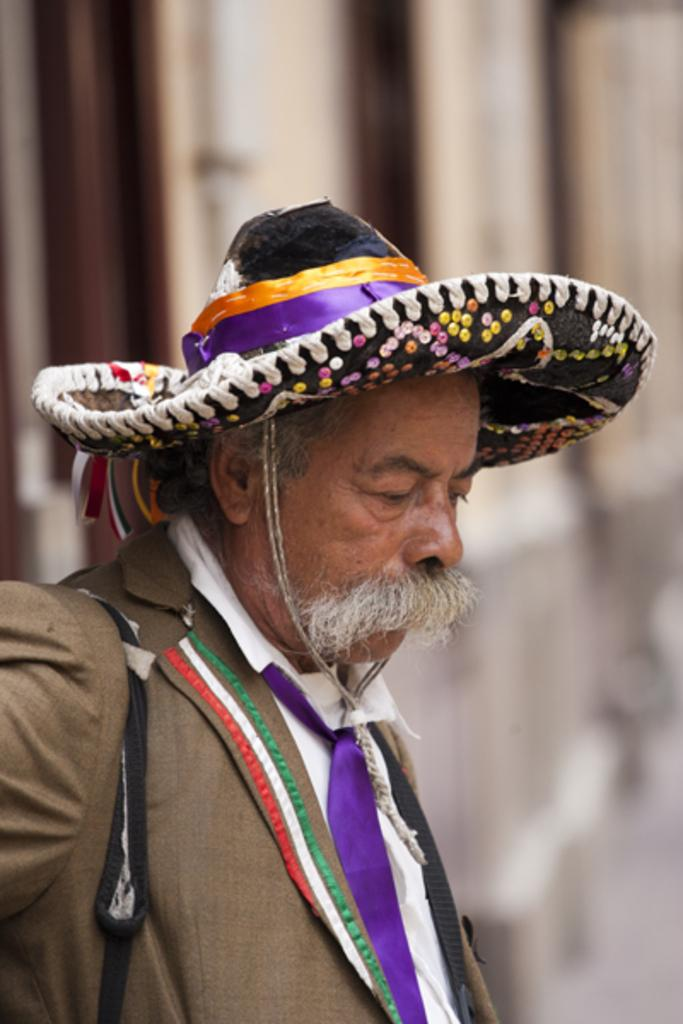What is the main subject of the image? There is a person standing in the image. What is the person wearing on their upper body? The person is wearing a brown color blazer. What type of accessory is the person wearing around their neck? The person is wearing a purple color tie. What type of headwear is the person wearing? The person is wearing a cap. How would you describe the background of the image? The background of the image is blurred. Can you tell me how many guides are present in the image? There are no guides present in the image; it features a person wearing a blazer, tie, and cap. What type of vase can be seen on the person's head? There is no vase present on the person's head; they are wearing a cap. 